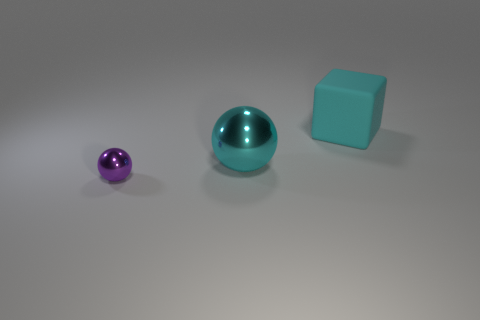Add 3 big rubber cylinders. How many objects exist? 6 Subtract all purple spheres. How many spheres are left? 1 Subtract all blocks. How many objects are left? 2 Subtract all red blocks. How many purple spheres are left? 1 Subtract all tiny blue metal cylinders. Subtract all spheres. How many objects are left? 1 Add 1 tiny purple balls. How many tiny purple balls are left? 2 Add 2 red balls. How many red balls exist? 2 Subtract 0 gray cylinders. How many objects are left? 3 Subtract 1 blocks. How many blocks are left? 0 Subtract all red blocks. Subtract all red balls. How many blocks are left? 1 